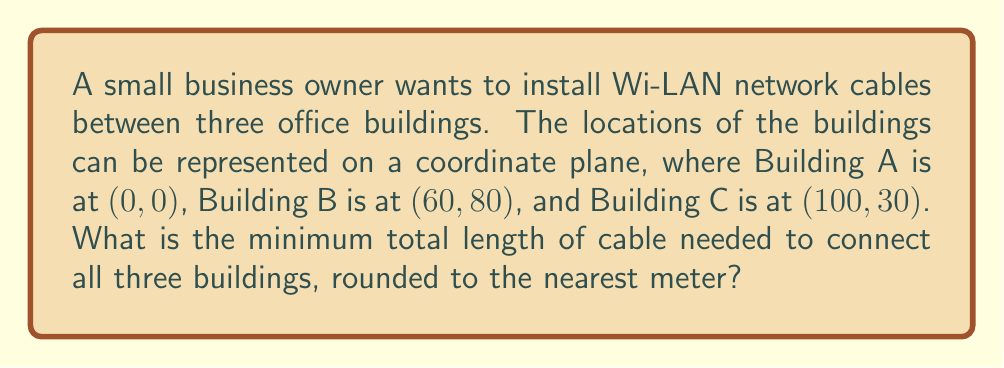Show me your answer to this math problem. To find the minimum total length of cable needed, we need to calculate the shortest path that connects all three buildings. This is equivalent to finding the minimum spanning tree of the three points.

Step 1: Calculate the distances between each pair of buildings using the distance formula:
$d = \sqrt{(x_2-x_1)^2 + (y_2-y_1)^2}$

Distance AB: $d_{AB} = \sqrt{(60-0)^2 + (80-0)^2} = \sqrt{3600 + 6400} = \sqrt{10000} = 100$ m
Distance BC: $d_{BC} = \sqrt{(100-60)^2 + (30-80)^2} = \sqrt{1600 + 2500} = \sqrt{4100} \approx 64.03$ m
Distance AC: $d_{AC} = \sqrt{(100-0)^2 + (30-0)^2} = \sqrt{10000 + 900} = \sqrt{10900} \approx 104.40$ m

Step 2: Determine the shortest path
The shortest path will be the sum of the two shortest distances. In this case, it's AB + BC.

Total length = $d_{AB} + d_{BC} = 100 + 64.03 = 164.03$ m

Step 3: Round to the nearest meter
164.03 m rounds to 164 m

[asy]
unitsize(2mm);
pair A = (0,0), B = (60,80), C = (100,30);
draw(A--B--C,blue);
dot(A); dot(B); dot(C);
label("A", A, SW);
label("B", B, NE);
label("C", C, SE);
label("100 m", (A+B)/2, NW);
label("64 m", (B+C)/2, SE);
[/asy]
Answer: 164 m 